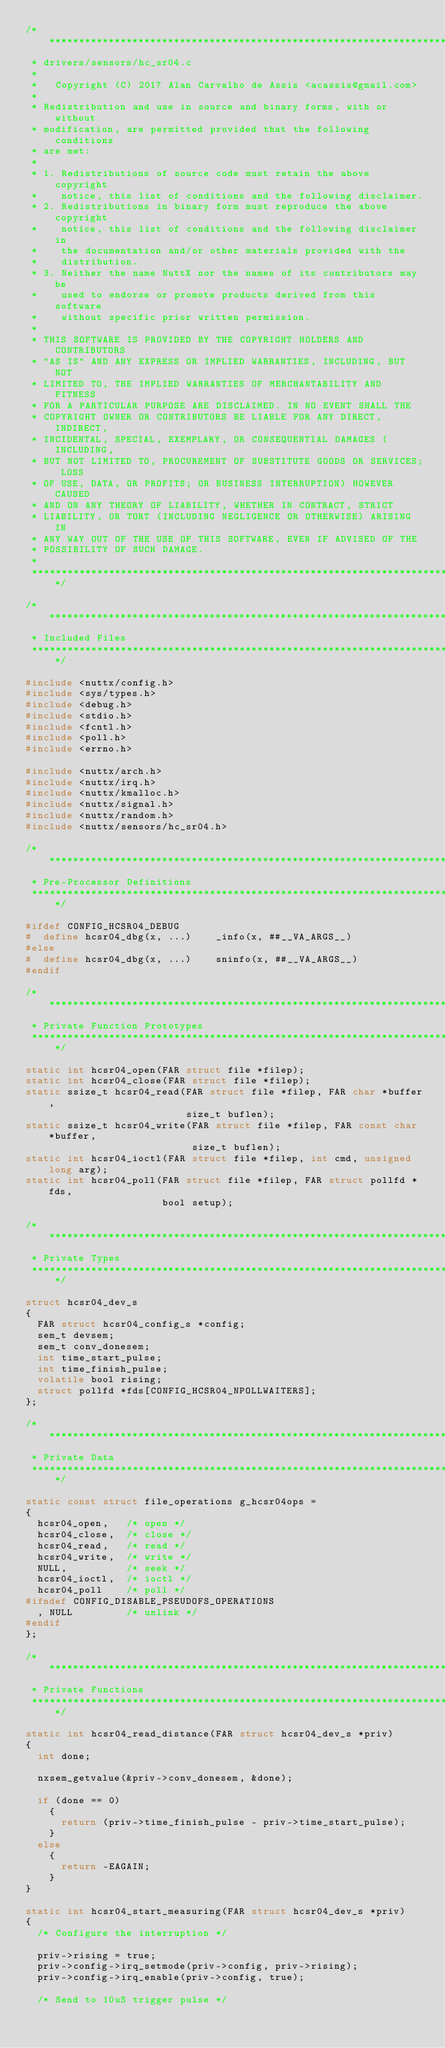Convert code to text. <code><loc_0><loc_0><loc_500><loc_500><_C_>/****************************************************************************
 * drivers/sensors/hc_sr04.c
 *
 *   Copyright (C) 2017 Alan Carvalho de Assis <acassis@gmail.com>
 *
 * Redistribution and use in source and binary forms, with or without
 * modification, are permitted provided that the following conditions
 * are met:
 *
 * 1. Redistributions of source code must retain the above copyright
 *    notice, this list of conditions and the following disclaimer.
 * 2. Redistributions in binary form must reproduce the above copyright
 *    notice, this list of conditions and the following disclaimer in
 *    the documentation and/or other materials provided with the
 *    distribution.
 * 3. Neither the name NuttX nor the names of its contributors may be
 *    used to endorse or promote products derived from this software
 *    without specific prior written permission.
 *
 * THIS SOFTWARE IS PROVIDED BY THE COPYRIGHT HOLDERS AND CONTRIBUTORS
 * "AS IS" AND ANY EXPRESS OR IMPLIED WARRANTIES, INCLUDING, BUT NOT
 * LIMITED TO, THE IMPLIED WARRANTIES OF MERCHANTABILITY AND FITNESS
 * FOR A PARTICULAR PURPOSE ARE DISCLAIMED. IN NO EVENT SHALL THE
 * COPYRIGHT OWNER OR CONTRIBUTORS BE LIABLE FOR ANY DIRECT, INDIRECT,
 * INCIDENTAL, SPECIAL, EXEMPLARY, OR CONSEQUENTIAL DAMAGES (INCLUDING,
 * BUT NOT LIMITED TO, PROCUREMENT OF SUBSTITUTE GOODS OR SERVICES; LOSS
 * OF USE, DATA, OR PROFITS; OR BUSINESS INTERRUPTION) HOWEVER CAUSED
 * AND ON ANY THEORY OF LIABILITY, WHETHER IN CONTRACT, STRICT
 * LIABILITY, OR TORT (INCLUDING NEGLIGENCE OR OTHERWISE) ARISING IN
 * ANY WAY OUT OF THE USE OF THIS SOFTWARE, EVEN IF ADVISED OF THE
 * POSSIBILITY OF SUCH DAMAGE.
 *
 ****************************************************************************/

/****************************************************************************
 * Included Files
 ****************************************************************************/

#include <nuttx/config.h>
#include <sys/types.h>
#include <debug.h>
#include <stdio.h>
#include <fcntl.h>
#include <poll.h>
#include <errno.h>

#include <nuttx/arch.h>
#include <nuttx/irq.h>
#include <nuttx/kmalloc.h>
#include <nuttx/signal.h>
#include <nuttx/random.h>
#include <nuttx/sensors/hc_sr04.h>

/****************************************************************************
 * Pre-Processor Definitions
 ****************************************************************************/

#ifdef CONFIG_HCSR04_DEBUG
#  define hcsr04_dbg(x, ...)    _info(x, ##__VA_ARGS__)
#else
#  define hcsr04_dbg(x, ...)    sninfo(x, ##__VA_ARGS__)
#endif

/****************************************************************************
 * Private Function Prototypes
 ****************************************************************************/

static int hcsr04_open(FAR struct file *filep);
static int hcsr04_close(FAR struct file *filep);
static ssize_t hcsr04_read(FAR struct file *filep, FAR char *buffer,
                           size_t buflen);
static ssize_t hcsr04_write(FAR struct file *filep, FAR const char *buffer,
                            size_t buflen);
static int hcsr04_ioctl(FAR struct file *filep, int cmd, unsigned long arg);
static int hcsr04_poll(FAR struct file *filep, FAR struct pollfd *fds,
                       bool setup);

/****************************************************************************
 * Private Types
 ****************************************************************************/

struct hcsr04_dev_s
{
  FAR struct hcsr04_config_s *config;
  sem_t devsem;
  sem_t conv_donesem;
  int time_start_pulse;
  int time_finish_pulse;
  volatile bool rising;
  struct pollfd *fds[CONFIG_HCSR04_NPOLLWAITERS];
};

/****************************************************************************
 * Private Data
 ****************************************************************************/

static const struct file_operations g_hcsr04ops =
{
  hcsr04_open,   /* open */
  hcsr04_close,  /* close */
  hcsr04_read,   /* read */
  hcsr04_write,  /* write */
  NULL,          /* seek */
  hcsr04_ioctl,  /* ioctl */
  hcsr04_poll    /* poll */
#ifndef CONFIG_DISABLE_PSEUDOFS_OPERATIONS
  , NULL         /* unlink */
#endif
};

/****************************************************************************
 * Private Functions
 ****************************************************************************/

static int hcsr04_read_distance(FAR struct hcsr04_dev_s *priv)
{
  int done;

  nxsem_getvalue(&priv->conv_donesem, &done);

  if (done == 0)
    {
      return (priv->time_finish_pulse - priv->time_start_pulse);
    }
  else
    {
      return -EAGAIN;
    }
}

static int hcsr04_start_measuring(FAR struct hcsr04_dev_s *priv)
{
  /* Configure the interruption */

  priv->rising = true;
  priv->config->irq_setmode(priv->config, priv->rising);
  priv->config->irq_enable(priv->config, true);

  /* Send to 10uS trigger pulse */
</code> 